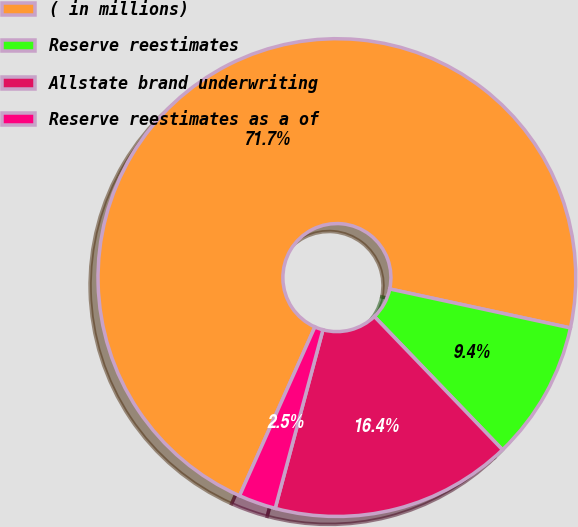Convert chart. <chart><loc_0><loc_0><loc_500><loc_500><pie_chart><fcel>( in millions)<fcel>Reserve reestimates<fcel>Allstate brand underwriting<fcel>Reserve reestimates as a of<nl><fcel>71.7%<fcel>9.43%<fcel>16.35%<fcel>2.52%<nl></chart> 